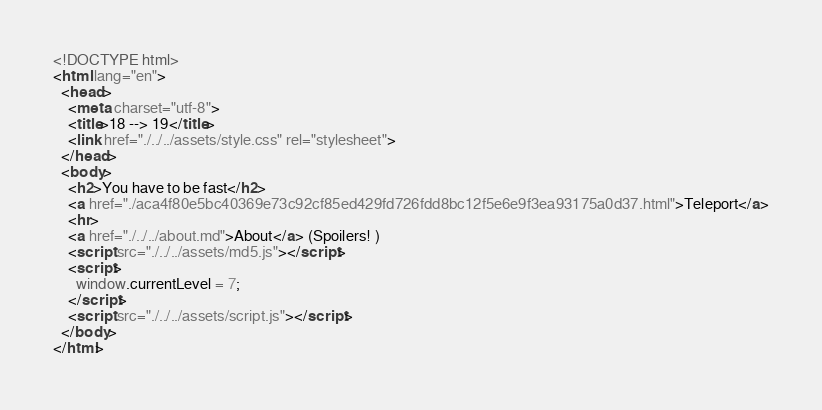<code> <loc_0><loc_0><loc_500><loc_500><_HTML_><!DOCTYPE html>
<html lang="en">
  <head>
    <meta charset="utf-8">
    <title>18 --> 19</title>
    <link href="./../../assets/style.css" rel="stylesheet">
  </head>
  <body>
    <h2>You have to be fast</h2>
    <a href="./aca4f80e5bc40369e73c92cf85ed429fd726fdd8bc12f5e6e9f3ea93175a0d37.html">Teleport</a>
    <hr>
    <a href="./../../about.md">About</a> (Spoilers! )
    <script src="./../../assets/md5.js"></script>
    <script>
      window.currentLevel = 7;
    </script>
    <script src="./../../assets/script.js"></script>
  </body>
</html></code> 